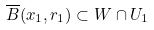Convert formula to latex. <formula><loc_0><loc_0><loc_500><loc_500>\overline { B } ( x _ { 1 } , r _ { 1 } ) \subset W \cap U _ { 1 }</formula> 